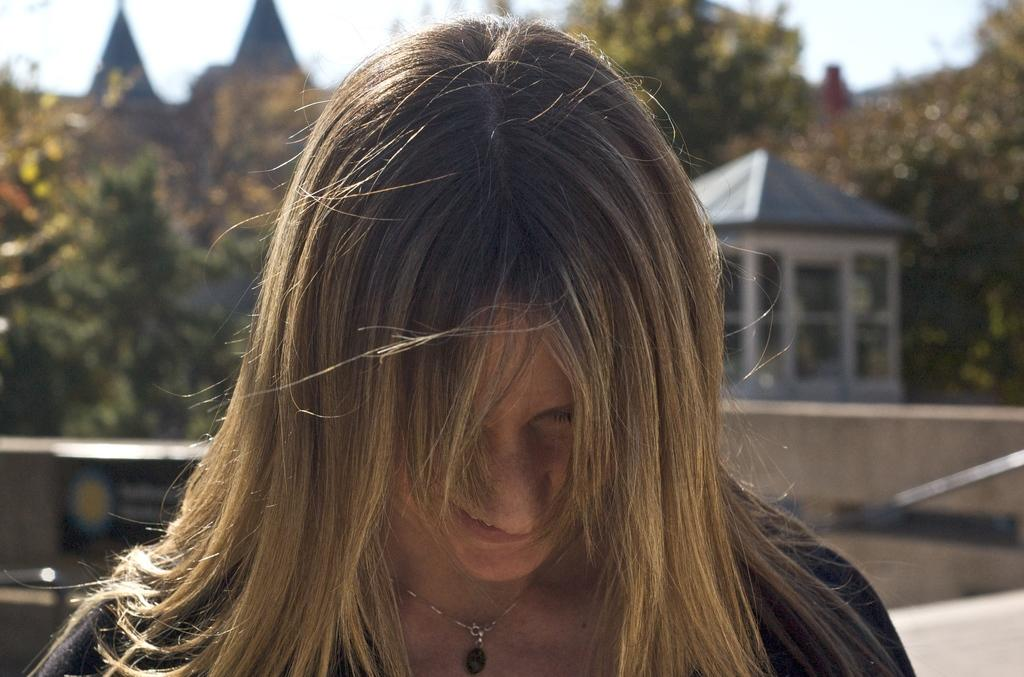What is the woman in the image doing? The woman is standing in the image and smiling. What can be seen in the background of the image? There is a building, trees, and a wall in the background of the image. What is the condition of the sky in the image? The sky is clear in the image. What type of ship can be seen sailing in the background of the image? There is no ship present in the image; it features a woman standing with a clear sky and a background that includes a building, trees, and a wall. What country is the woman from, as indicated by the letter on her shirt? There is no letter or indication of a country on the woman's shirt in the image. 